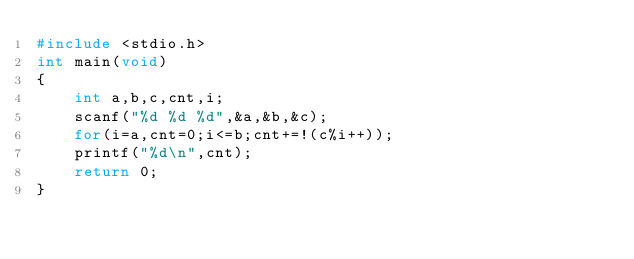<code> <loc_0><loc_0><loc_500><loc_500><_C_>#include <stdio.h>
int main(void)
{
    int a,b,c,cnt,i;
    scanf("%d %d %d",&a,&b,&c);
    for(i=a,cnt=0;i<=b;cnt+=!(c%i++));
    printf("%d\n",cnt);
    return 0;
}
</code> 